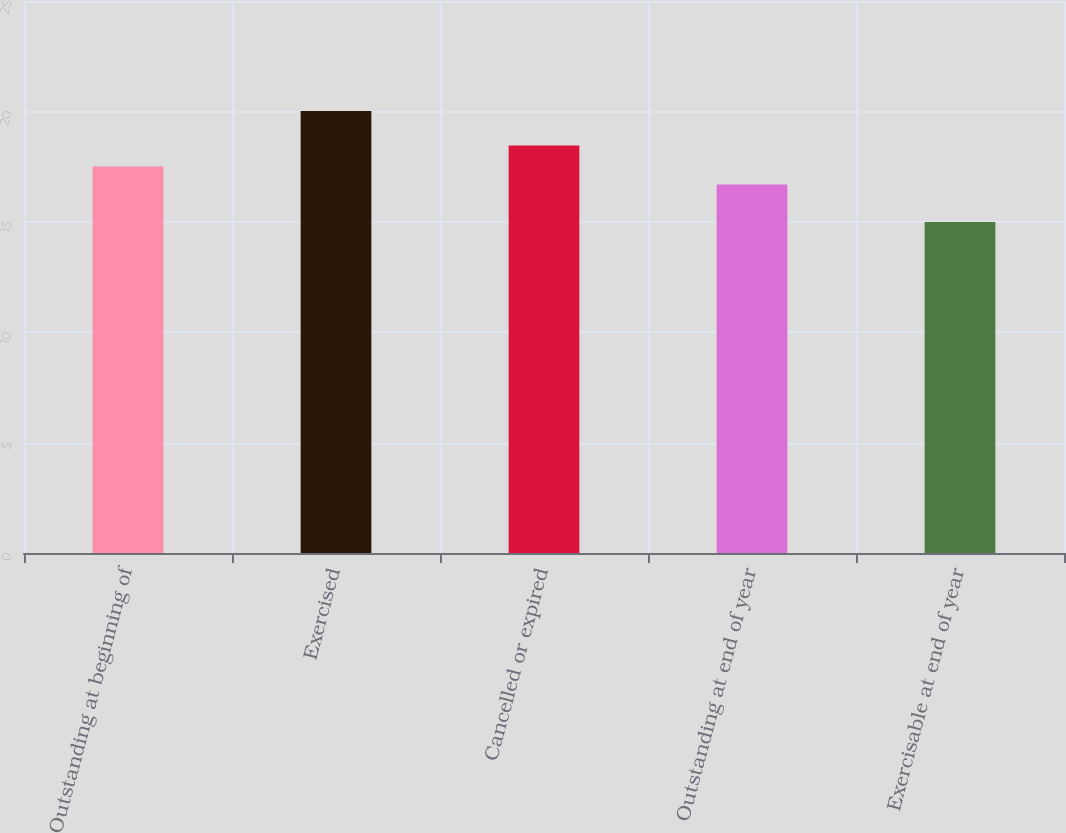Convert chart. <chart><loc_0><loc_0><loc_500><loc_500><bar_chart><fcel>Outstanding at beginning of<fcel>Exercised<fcel>Cancelled or expired<fcel>Outstanding at end of year<fcel>Exercisable at end of year<nl><fcel>17.5<fcel>20.02<fcel>18.45<fcel>16.69<fcel>14.99<nl></chart> 